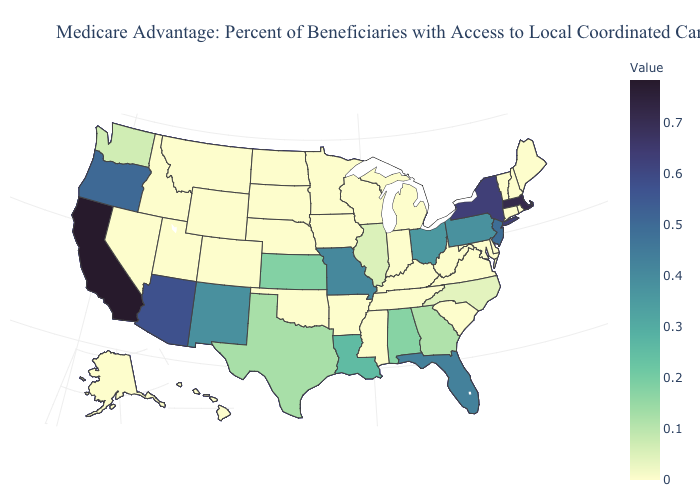Does the map have missing data?
Short answer required. No. Does Indiana have a lower value than New Jersey?
Concise answer only. Yes. Does Mississippi have a higher value than Pennsylvania?
Concise answer only. No. Does Vermont have the highest value in the Northeast?
Short answer required. No. 